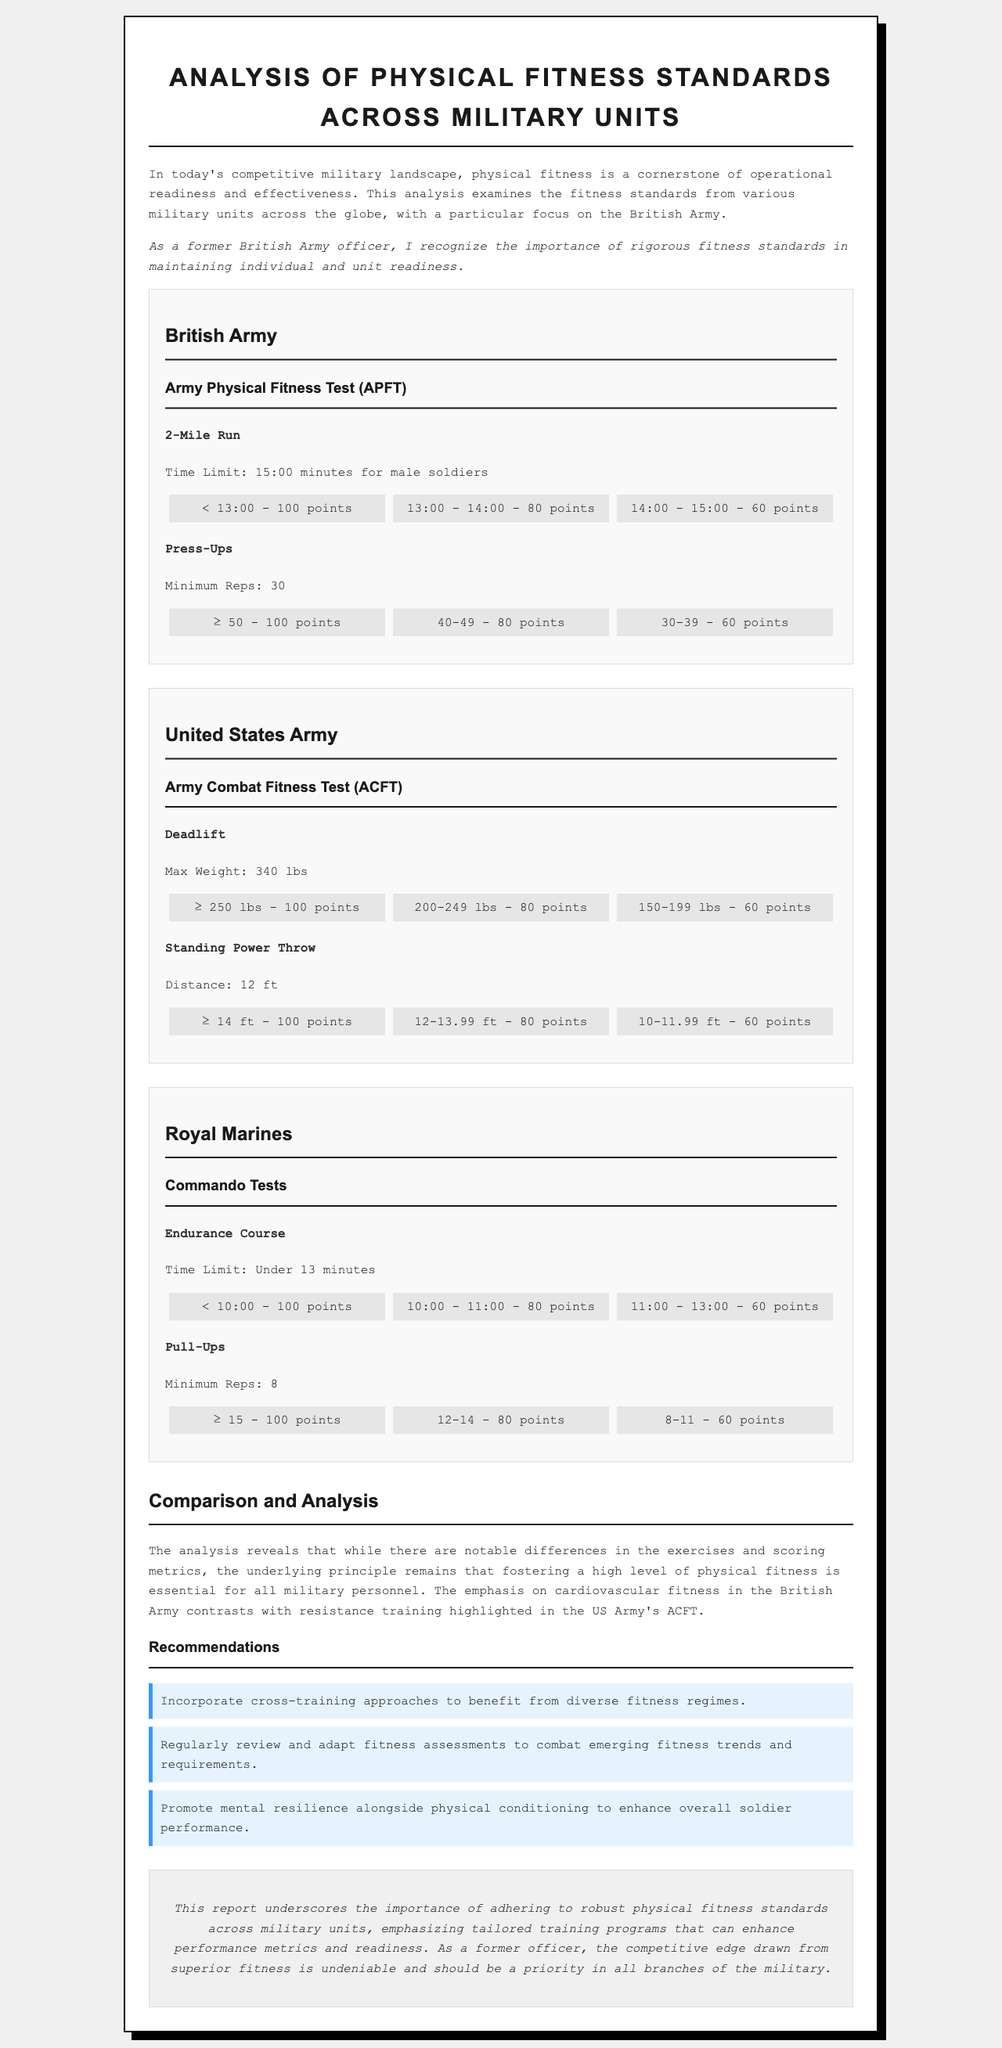what is the time limit for the 2-mile run in the British Army? The time limit for the 2-mile run for male soldiers in the British Army is 15:00 minutes.
Answer: 15:00 minutes what is the maximum weight for the deadlift in the United States Army? The maximum weight for the deadlift in the United States Army is 340 lbs.
Answer: 340 lbs what score corresponds to 40-49 push-ups in the British Army standards? For 40-49 push-ups, the score in the British Army standards is 80 points.
Answer: 80 points which military unit emphasizes resistance training in its fitness test? The United States Army emphasizes resistance training in its Army Combat Fitness Test (ACFT).
Answer: United States Army what is a recommended approach to improve fitness standards according to the report? One recommendation to improve fitness standards is to incorporate cross-training approaches.
Answer: Incorporate cross-training approaches how many minimum pull-ups are required in the Royal Marines Commando Tests? The minimum pull-ups required in the Royal Marines Commando Tests is 8.
Answer: 8 what is the time limit for completing the Endurance Course in the Royal Marines? The time limit for the Endurance Course in the Royal Marines is under 13 minutes.
Answer: Under 13 minutes what is the relationship between physical fitness and operational readiness mentioned in the introduction? The introduction states that physical fitness is a cornerstone of operational readiness and effectiveness.
Answer: Cornerstone of operational readiness what scoring system is used in the British Army for the 2-mile run? The scoring system for the 2-mile run in the British Army is based on time, with different point brackets for completion times.
Answer: Based on time 